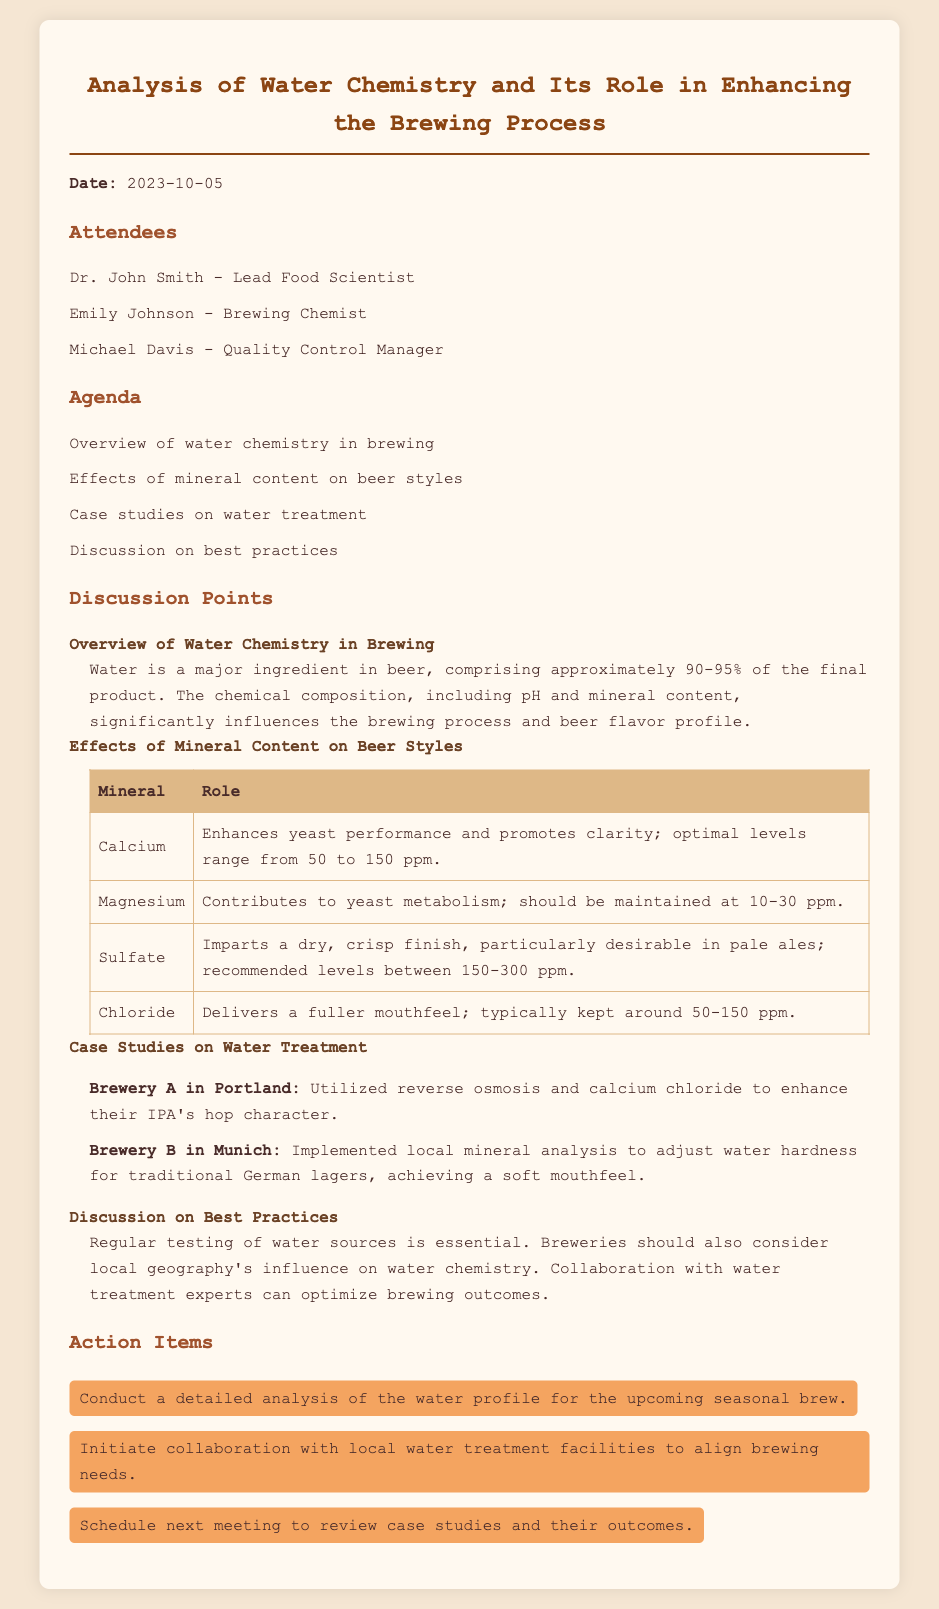What is the date of the meeting? The date of the meeting is stated prominently at the top of the document.
Answer: 2023-10-05 Who was the Lead Food Scientist? The document lists the attendees and identifies the lead food scientist among them.
Answer: Dr. John Smith What mineral enhances yeast performance? The document provides information on minerals and their roles in brewing.
Answer: Calcium What is the recommended level of sulfate for pale ales? The table in the document specifies the optimal range for sulfate levels.
Answer: 150-300 ppm What was the focus of Brewery A's water treatment? The case study section highlights Brewery A's approach to water treatment and its objectives.
Answer: Enhance IPA's hop character How often should water sources be tested? The best practices section emphasizes the importance of regular testing.
Answer: Regularly What type of analysis is suggested for the upcoming seasonal brew? Action items detail the specific actions to be taken for future brews.
Answer: Detailed analysis of the water profile What is the role of chloride in beer? The document includes specifics about the effects of minerals on beer styles.
Answer: Delivers a fuller mouthfeel 